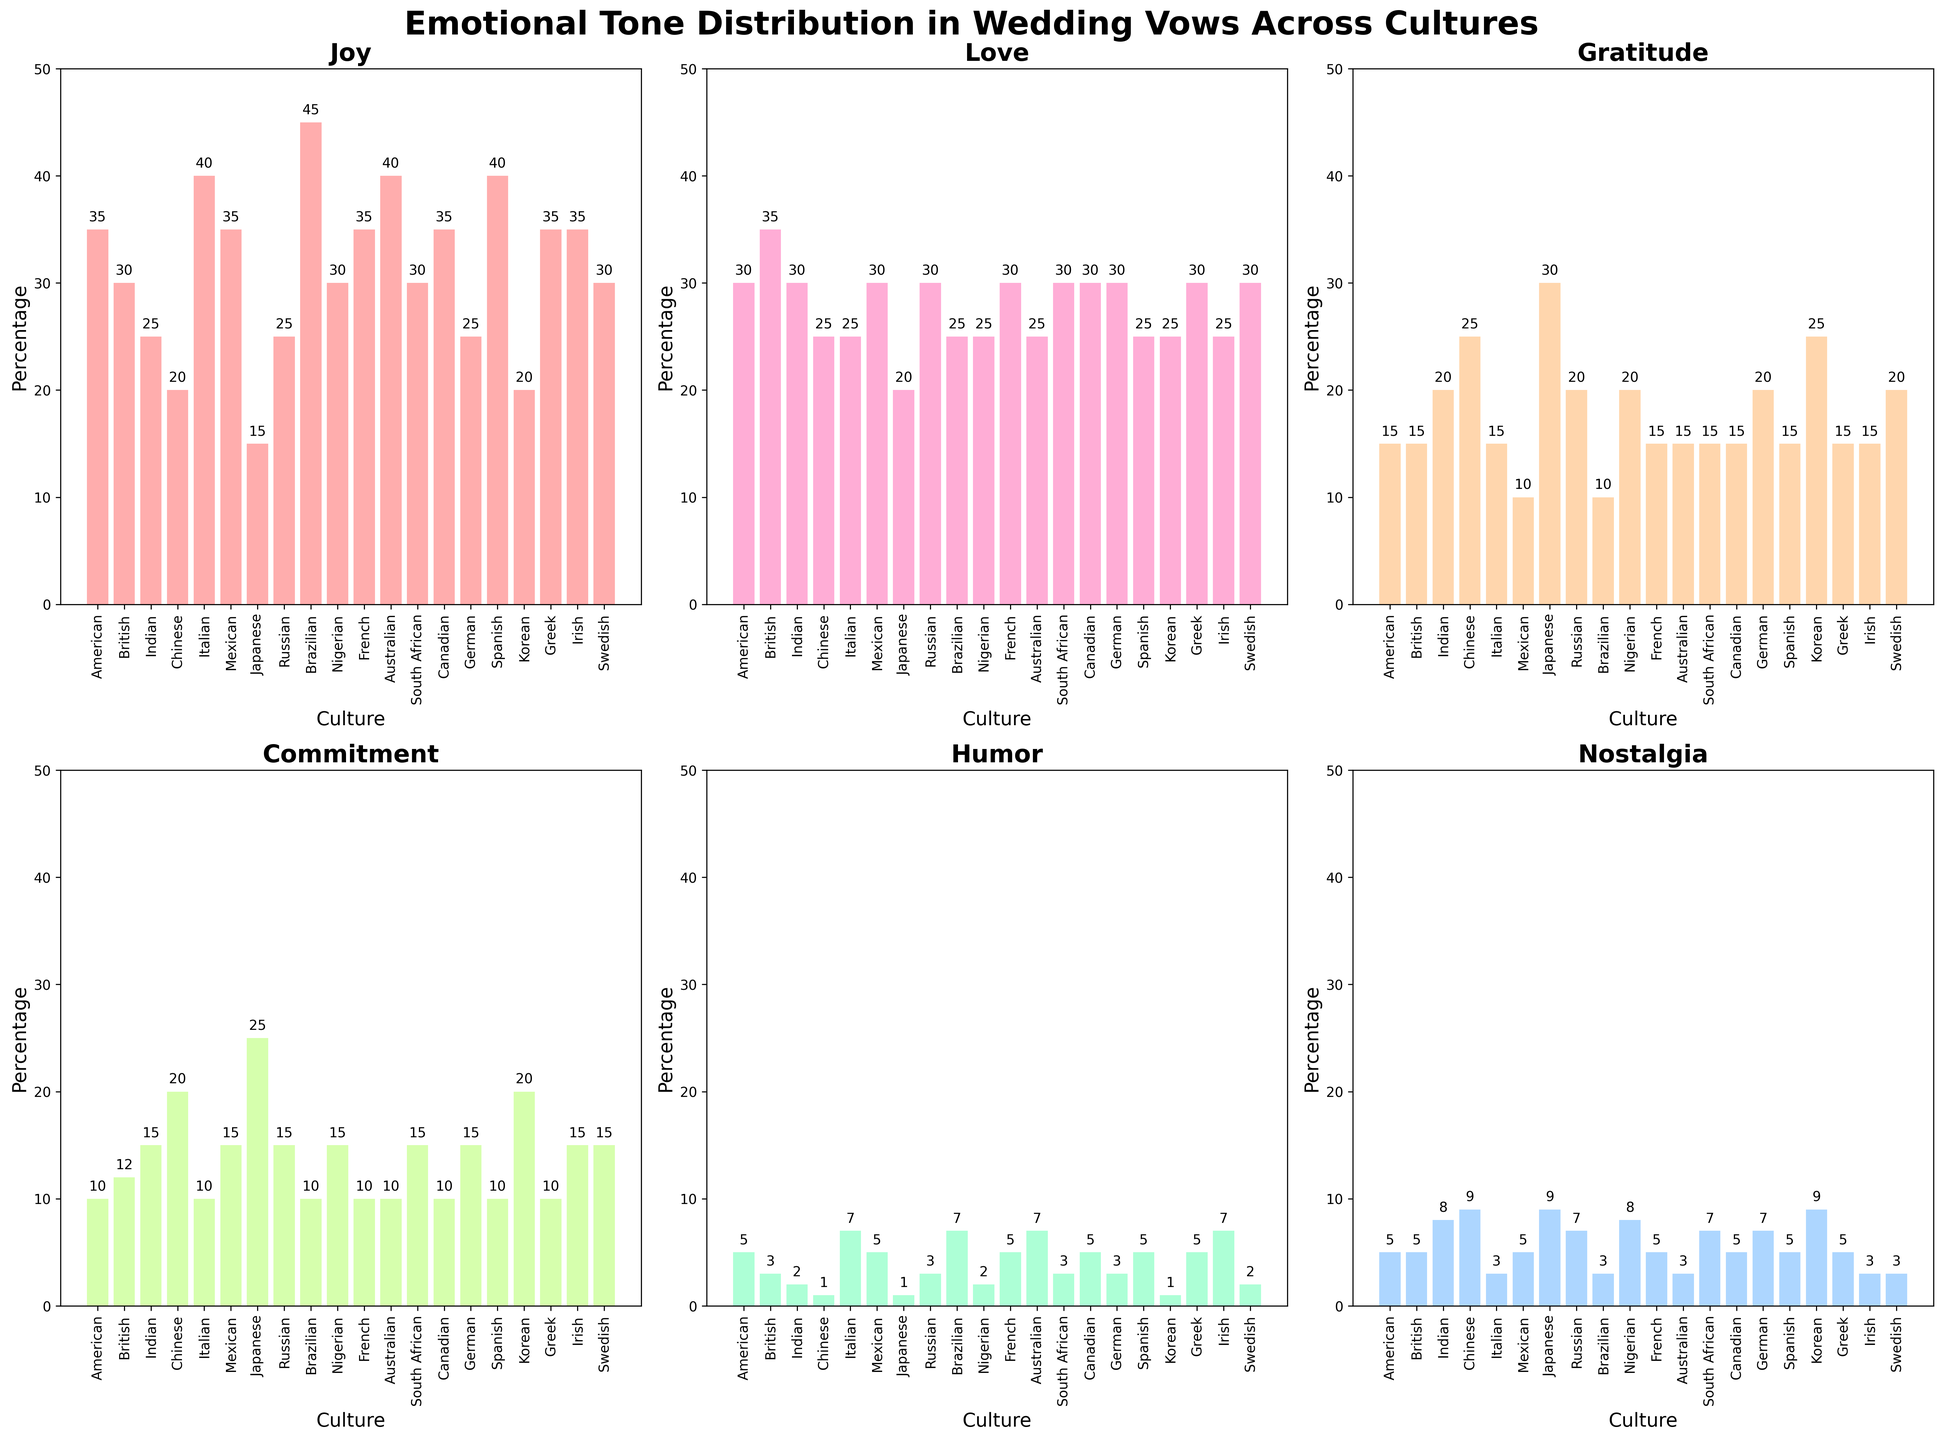Which culture has the highest percentage of 'joy' in their wedding vows? Looking at the subplot for 'joy', the tallest bar represents Brazilian culture with a value of 45.
Answer: Brazilian Which two cultures have the same percentage of 'humor' in their vows? In the 'humor' subplot, we observe this by finding cultures with the same bar height. Both Australian and Italian cultures show 7%.
Answer: Australian and Italian What's the sum of the 'commitment' percentages for Chinese and Japanese cultures? In the 'commitment' subplot, locate the bars for Chinese (20%) and Japanese (25%) and add them together: 20 + 25 = 45.
Answer: 45 Which emotion has the smallest range across all cultures? Compare the heights of all bars in each subplot to find the smallest difference between the highest and lowest values. 'Gratitude' spans from 10 to 30 (a range of 20%).
Answer: Nostalgia What is the average percentage of 'love' across all cultures? Sum all the values for 'love' and divide by the number of cultures (20): (30 + 35 + 30 + 25 + 25 + 30 + 30 + 30 + 25 + 25 + 30 + 25 + 30 + 30 + 30 + 25 + 25 + 30 + 25 + 25) = 580. Therefore, 580 / 20 = 29.
Answer: 29 Which culture shows the greatest variability in emotional tone distribution among all types of emotions? Compare the range (maximum minus minimum) of values within each culture. For example, Brazilian ranges from 10 to 45 (a range of 35). Check every culture to find the highest variability.
Answer: Brazilian In terms of 'nostalgia', which two cultures have the highest values? Look at the 'nostalgia' subplot and identify the tallest two bars, which belong to Chinese and Japanese cultures with values of 9 each.
Answer: Chinese and Japanese Is there any culture that shows the same percentage for three different emotions? Look for any culture's sub-bars that repeat three times. No culture in the figure exhibits the same value for three distinct emotions.
Answer: No Consider 'joy' and 'love' together; which culture has the highest combined percentage for these emotions? Add the 'joy' and 'love' values for each culture and find the highest sum. Brazilian scores highest with 'joy' 45 and 'love' 25, making a total of 70.
Answer: Brazilian Which culture places the least emphasis on 'commitment' in their vows? Find the shortest bar in the 'commitment' subplot, which is from Italian culture at 10%.
Answer: Italian 